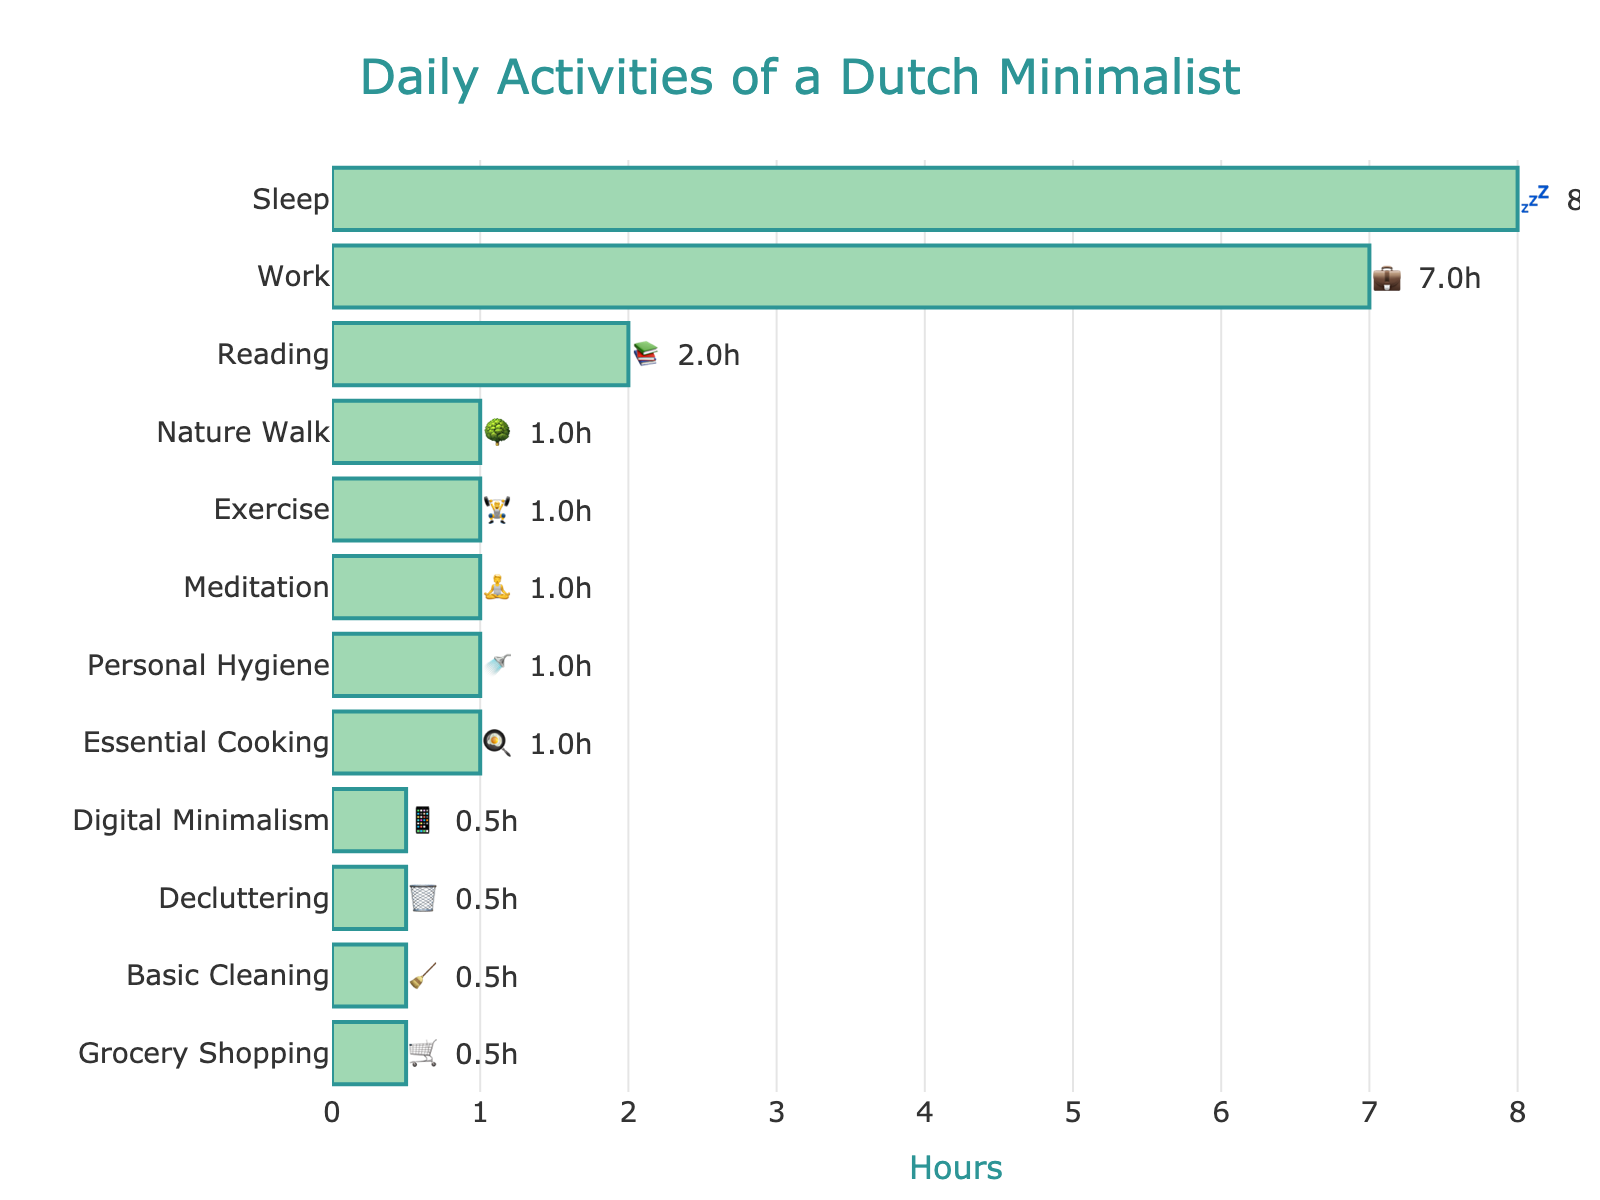What is the overall title of the chart? The title is located at the top center of the chart in a larger font size and distinctive color.
Answer: Daily Activities of a Dutch Minimalist How many hours per day are spent on exercise? The bar labeled "Exercise" with its respective emoji 🏋️ shows the number of hours.
Answer: 1 hour Which activity takes up the most time, according to the chart? By looking at the longest bar in the chart, we can identify the activity with the most hours.
Answer: Sleep What is the combined time spent on essential cooking, grocery shopping, and basic cleaning? Summing the hours for Essential Cooking (1h), Grocery Shopping (0.5h), and Basic Cleaning (0.5h) gives the total.
Answer: 2 hours How does the time spent on reading compare to the time spent on work? Reading has a bar of 2h while work has a bar of 7h, clearly indicated by their lengths and labels.
Answer: The time spent on reading is 5 hours less than the time spent on work Which non-essential activity consumes the second most amount of time? Sorting the non-essential activities by the length of their bars, Reading (📚 2h) comes after Work.
Answer: Reading If we exclude sleep, what is the average time spent on the remaining activities? Summing the hours for all activities except Sleep (8h) and dividing by the number of activities excluding Sleep (11) yields the average. (7 + 1 + 0.5 + 0.5 + 1 + 2 + 1 + 1 + 0.5 + 0.5 + 1) / 11 = 16 / 11 ≈ 1.45h
Answer: 1.45 hours Which activity related to minimalism takes the least amount of time? Among minimalism activities (Digital Minimalism, Decluttering), Digital Minimalism has the smaller bar of 0.5h.
Answer: Digital Minimalism What is the total time allocated to personal care activities? Adding the hours for Personal Hygiene (1h) and Exercise (1h) gives their combined total.
Answer: 2 hours How much more time is spent on work compared to meditation? Work takes 7 hours and meditation takes 1 hour; subtracting these gives the difference.
Answer: 6 hours 